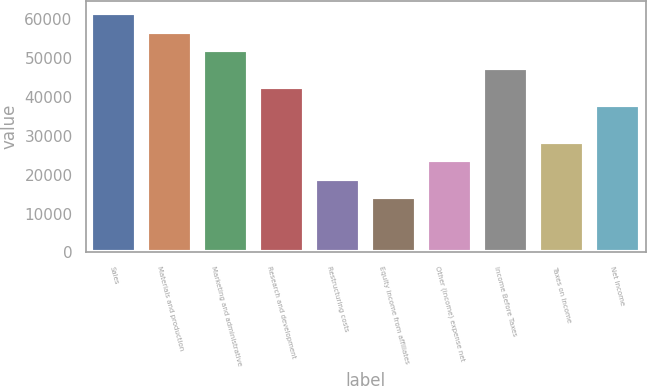Convert chart. <chart><loc_0><loc_0><loc_500><loc_500><bar_chart><fcel>Sales<fcel>Materials and production<fcel>Marketing and administrative<fcel>Research and development<fcel>Restructuring costs<fcel>Equity income from affiliates<fcel>Other (income) expense net<fcel>Income Before Taxes<fcel>Taxes on Income<fcel>Net Income<nl><fcel>61446.5<fcel>56720<fcel>51993.5<fcel>42540.5<fcel>18908<fcel>14181.5<fcel>23634.5<fcel>47267<fcel>28361<fcel>37814<nl></chart> 